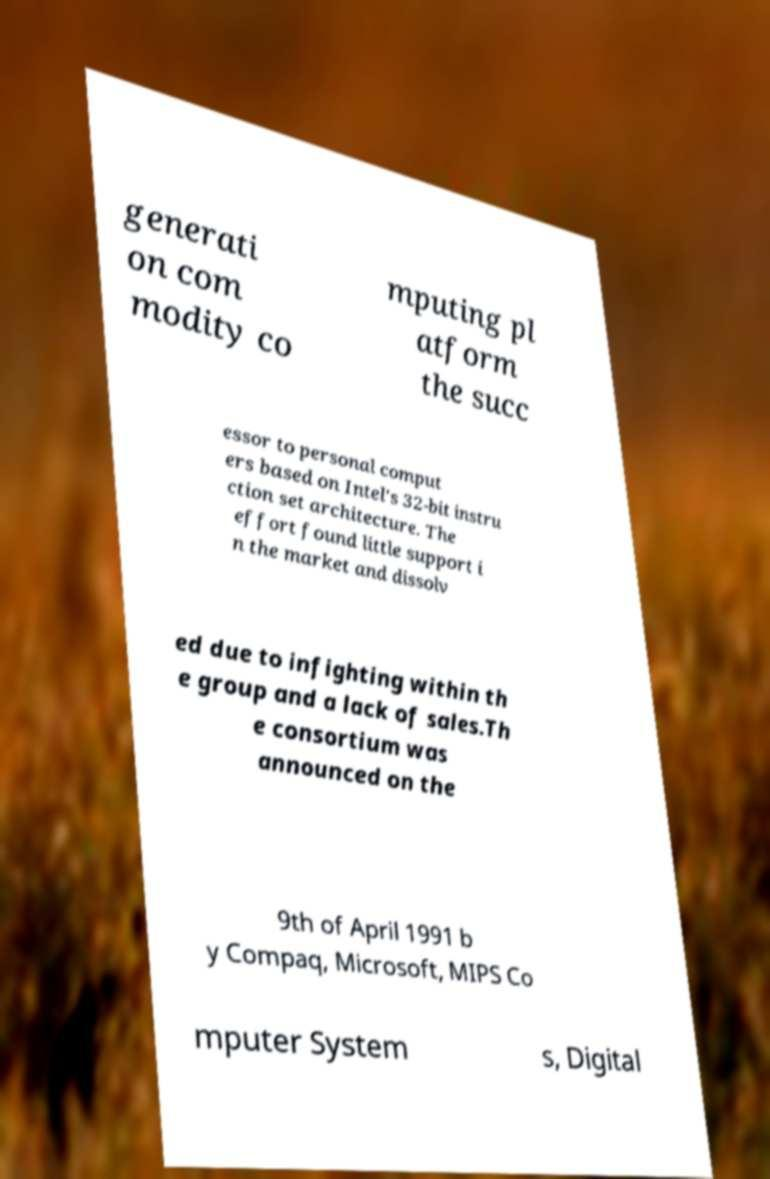Can you read and provide the text displayed in the image?This photo seems to have some interesting text. Can you extract and type it out for me? generati on com modity co mputing pl atform the succ essor to personal comput ers based on Intel's 32-bit instru ction set architecture. The effort found little support i n the market and dissolv ed due to infighting within th e group and a lack of sales.Th e consortium was announced on the 9th of April 1991 b y Compaq, Microsoft, MIPS Co mputer System s, Digital 